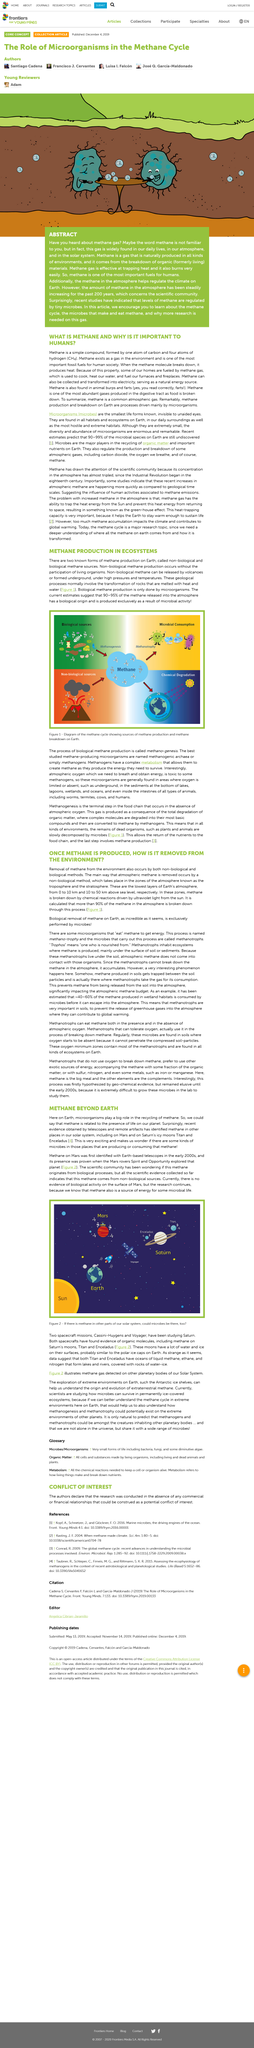Outline some significant characteristics in this image. Microorganisms play a vital role in the Earth's ecosystem, particularly in the recycling of methane. They are responsible for breaking down organic matter and converting it into simpler molecules, which are then used by other organisms as a source of energy and nutrients. The activity of microorganisms is essential for maintaining the balance of the Earth's ecosystem and for supporting the survival and growth of other organisms. Their ability to decompose organic matter and convert it into other forms of energy has significant implications for a wide range of biological, ecological, and environmental processes. The existence of methane on Mars has been proven by the exploration of Mars rovers Spirit and Opportunity, as illustrated in Figure 2. Methanogenesis is a biological process that produces methane as a byproduct. It is caused by microorganisms known as methanogens, which are found in the digestive system of certain organisms and in certain environments, such as marshes and oceans. Methanogenesis is a crucial process in the natural environment, as it helps to recycle carbon and maintain the balance of greenhouse gases in the atmosphere. However, the process can also be artificially induced through the use of methanogens in industrial applications, such as the production of biogas. Two spacecraft missions, Cassini-Huygens and Voyager, have been studying Saturn. Cassini-Huygens has been orbiting and exploring Saturn while Voyager has been studying Saturn from a distance. Both missions have provided valuable information about Saturn's atmosphere, moons, and rings. Methanogenic archaea, more commonly known as methanogens, are a group of microorganisms that are characterized by their ability to produce methane as a primary metabolic product. 